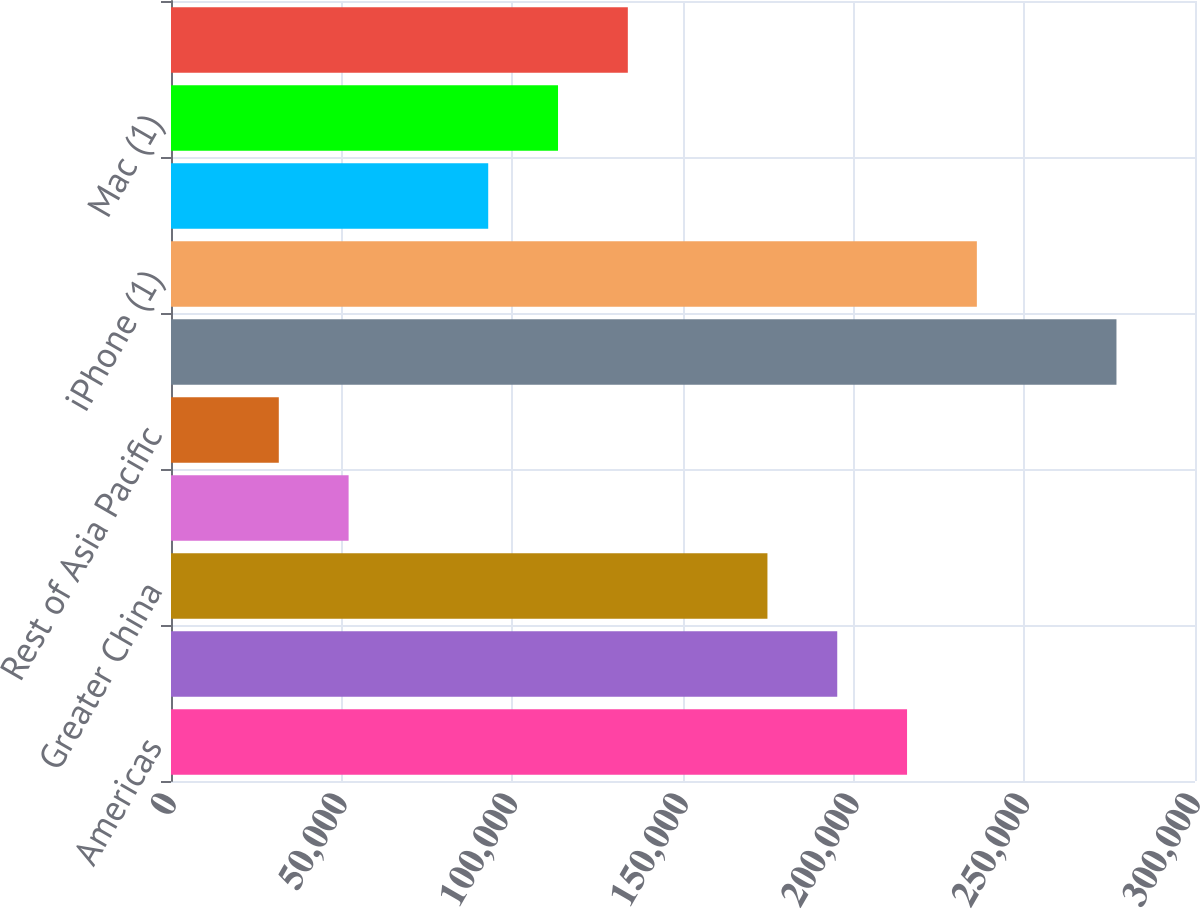Convert chart to OTSL. <chart><loc_0><loc_0><loc_500><loc_500><bar_chart><fcel>Americas<fcel>Europe<fcel>Greater China<fcel>Japan<fcel>Rest of Asia Pacific<fcel>Total net sales<fcel>iPhone (1)<fcel>iPad (1)<fcel>Mac (1)<fcel>Services (2)<nl><fcel>215639<fcel>195188<fcel>174738<fcel>52033.4<fcel>31582.7<fcel>276991<fcel>236090<fcel>92934.8<fcel>113386<fcel>133836<nl></chart> 